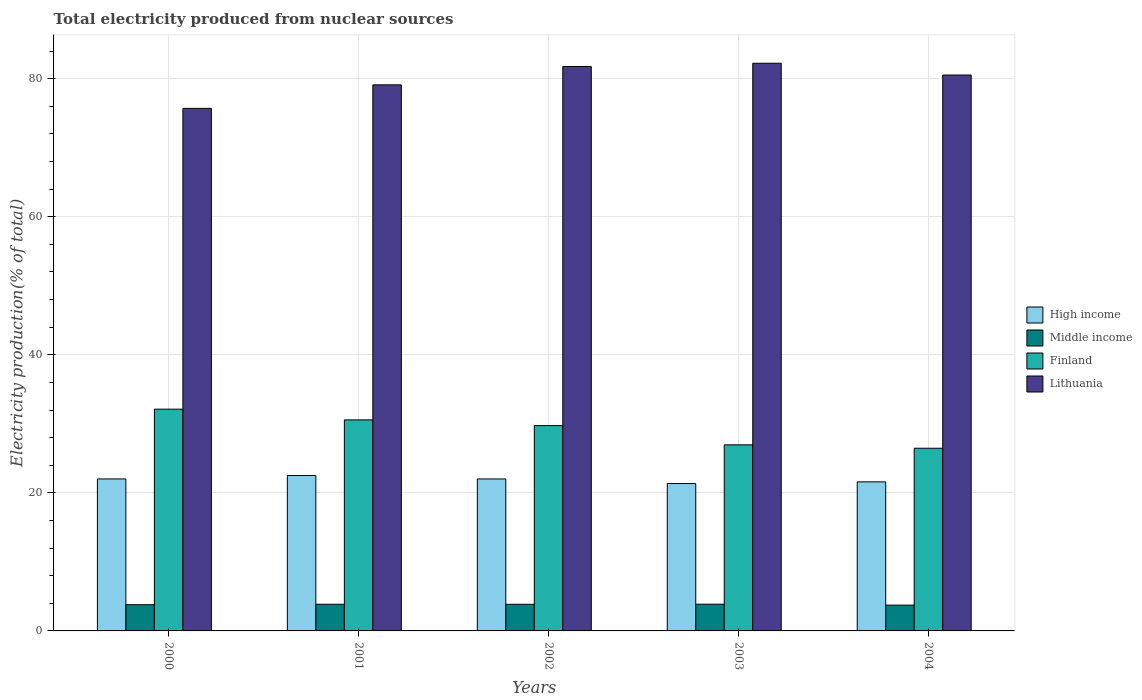How many different coloured bars are there?
Your answer should be very brief. 4. How many groups of bars are there?
Keep it short and to the point. 5. Are the number of bars on each tick of the X-axis equal?
Make the answer very short. Yes. What is the label of the 1st group of bars from the left?
Provide a succinct answer. 2000. In how many cases, is the number of bars for a given year not equal to the number of legend labels?
Offer a very short reply. 0. What is the total electricity produced in Middle income in 2003?
Your answer should be very brief. 3.87. Across all years, what is the maximum total electricity produced in High income?
Make the answer very short. 22.51. Across all years, what is the minimum total electricity produced in Middle income?
Your answer should be very brief. 3.74. In which year was the total electricity produced in Middle income maximum?
Provide a short and direct response. 2003. In which year was the total electricity produced in Lithuania minimum?
Give a very brief answer. 2000. What is the total total electricity produced in Middle income in the graph?
Provide a succinct answer. 19.13. What is the difference between the total electricity produced in High income in 2002 and that in 2004?
Offer a very short reply. 0.42. What is the difference between the total electricity produced in Middle income in 2001 and the total electricity produced in Lithuania in 2004?
Ensure brevity in your answer.  -76.67. What is the average total electricity produced in High income per year?
Offer a terse response. 21.9. In the year 2004, what is the difference between the total electricity produced in High income and total electricity produced in Middle income?
Your response must be concise. 17.86. In how many years, is the total electricity produced in Middle income greater than 12 %?
Ensure brevity in your answer.  0. What is the ratio of the total electricity produced in Lithuania in 2002 to that in 2004?
Your answer should be very brief. 1.02. Is the total electricity produced in High income in 2002 less than that in 2004?
Keep it short and to the point. No. Is the difference between the total electricity produced in High income in 2002 and 2003 greater than the difference between the total electricity produced in Middle income in 2002 and 2003?
Your answer should be compact. Yes. What is the difference between the highest and the second highest total electricity produced in Lithuania?
Make the answer very short. 0.47. What is the difference between the highest and the lowest total electricity produced in High income?
Provide a succinct answer. 1.16. Is it the case that in every year, the sum of the total electricity produced in Finland and total electricity produced in High income is greater than the sum of total electricity produced in Middle income and total electricity produced in Lithuania?
Offer a very short reply. Yes. What does the 2nd bar from the right in 2004 represents?
Your response must be concise. Finland. Is it the case that in every year, the sum of the total electricity produced in Lithuania and total electricity produced in High income is greater than the total electricity produced in Middle income?
Provide a short and direct response. Yes. Does the graph contain any zero values?
Your response must be concise. No. Where does the legend appear in the graph?
Keep it short and to the point. Center right. How are the legend labels stacked?
Keep it short and to the point. Vertical. What is the title of the graph?
Make the answer very short. Total electricity produced from nuclear sources. Does "Somalia" appear as one of the legend labels in the graph?
Make the answer very short. No. What is the label or title of the X-axis?
Your response must be concise. Years. What is the Electricity production(% of total) of High income in 2000?
Offer a terse response. 22.02. What is the Electricity production(% of total) in Middle income in 2000?
Keep it short and to the point. 3.8. What is the Electricity production(% of total) in Finland in 2000?
Provide a succinct answer. 32.13. What is the Electricity production(% of total) of Lithuania in 2000?
Make the answer very short. 75.7. What is the Electricity production(% of total) in High income in 2001?
Your response must be concise. 22.51. What is the Electricity production(% of total) in Middle income in 2001?
Make the answer very short. 3.86. What is the Electricity production(% of total) of Finland in 2001?
Keep it short and to the point. 30.57. What is the Electricity production(% of total) of Lithuania in 2001?
Your response must be concise. 79.11. What is the Electricity production(% of total) of High income in 2002?
Give a very brief answer. 22.02. What is the Electricity production(% of total) in Middle income in 2002?
Give a very brief answer. 3.86. What is the Electricity production(% of total) in Finland in 2002?
Offer a very short reply. 29.75. What is the Electricity production(% of total) in Lithuania in 2002?
Provide a short and direct response. 81.77. What is the Electricity production(% of total) of High income in 2003?
Offer a very short reply. 21.35. What is the Electricity production(% of total) of Middle income in 2003?
Your answer should be compact. 3.87. What is the Electricity production(% of total) in Finland in 2003?
Provide a succinct answer. 26.96. What is the Electricity production(% of total) in Lithuania in 2003?
Provide a succinct answer. 82.24. What is the Electricity production(% of total) of High income in 2004?
Give a very brief answer. 21.59. What is the Electricity production(% of total) of Middle income in 2004?
Offer a terse response. 3.74. What is the Electricity production(% of total) in Finland in 2004?
Ensure brevity in your answer.  26.47. What is the Electricity production(% of total) of Lithuania in 2004?
Your answer should be compact. 80.54. Across all years, what is the maximum Electricity production(% of total) in High income?
Provide a short and direct response. 22.51. Across all years, what is the maximum Electricity production(% of total) of Middle income?
Make the answer very short. 3.87. Across all years, what is the maximum Electricity production(% of total) of Finland?
Provide a short and direct response. 32.13. Across all years, what is the maximum Electricity production(% of total) of Lithuania?
Your response must be concise. 82.24. Across all years, what is the minimum Electricity production(% of total) of High income?
Provide a short and direct response. 21.35. Across all years, what is the minimum Electricity production(% of total) in Middle income?
Your response must be concise. 3.74. Across all years, what is the minimum Electricity production(% of total) in Finland?
Offer a very short reply. 26.47. Across all years, what is the minimum Electricity production(% of total) in Lithuania?
Keep it short and to the point. 75.7. What is the total Electricity production(% of total) in High income in the graph?
Your answer should be compact. 109.5. What is the total Electricity production(% of total) in Middle income in the graph?
Your answer should be very brief. 19.13. What is the total Electricity production(% of total) of Finland in the graph?
Your answer should be very brief. 145.88. What is the total Electricity production(% of total) in Lithuania in the graph?
Provide a short and direct response. 399.36. What is the difference between the Electricity production(% of total) of High income in 2000 and that in 2001?
Your response must be concise. -0.49. What is the difference between the Electricity production(% of total) in Middle income in 2000 and that in 2001?
Make the answer very short. -0.07. What is the difference between the Electricity production(% of total) in Finland in 2000 and that in 2001?
Your answer should be compact. 1.55. What is the difference between the Electricity production(% of total) of Lithuania in 2000 and that in 2001?
Keep it short and to the point. -3.41. What is the difference between the Electricity production(% of total) of High income in 2000 and that in 2002?
Provide a short and direct response. 0. What is the difference between the Electricity production(% of total) in Middle income in 2000 and that in 2002?
Your answer should be very brief. -0.06. What is the difference between the Electricity production(% of total) of Finland in 2000 and that in 2002?
Provide a short and direct response. 2.38. What is the difference between the Electricity production(% of total) in Lithuania in 2000 and that in 2002?
Provide a succinct answer. -6.07. What is the difference between the Electricity production(% of total) of High income in 2000 and that in 2003?
Provide a short and direct response. 0.67. What is the difference between the Electricity production(% of total) in Middle income in 2000 and that in 2003?
Your answer should be compact. -0.08. What is the difference between the Electricity production(% of total) of Finland in 2000 and that in 2003?
Make the answer very short. 5.17. What is the difference between the Electricity production(% of total) of Lithuania in 2000 and that in 2003?
Make the answer very short. -6.54. What is the difference between the Electricity production(% of total) in High income in 2000 and that in 2004?
Give a very brief answer. 0.43. What is the difference between the Electricity production(% of total) in Middle income in 2000 and that in 2004?
Your answer should be very brief. 0.06. What is the difference between the Electricity production(% of total) in Finland in 2000 and that in 2004?
Provide a succinct answer. 5.66. What is the difference between the Electricity production(% of total) of Lithuania in 2000 and that in 2004?
Offer a very short reply. -4.83. What is the difference between the Electricity production(% of total) of High income in 2001 and that in 2002?
Your response must be concise. 0.49. What is the difference between the Electricity production(% of total) in Middle income in 2001 and that in 2002?
Provide a short and direct response. 0. What is the difference between the Electricity production(% of total) of Finland in 2001 and that in 2002?
Your answer should be compact. 0.83. What is the difference between the Electricity production(% of total) in Lithuania in 2001 and that in 2002?
Ensure brevity in your answer.  -2.66. What is the difference between the Electricity production(% of total) in High income in 2001 and that in 2003?
Provide a succinct answer. 1.16. What is the difference between the Electricity production(% of total) in Middle income in 2001 and that in 2003?
Offer a very short reply. -0.01. What is the difference between the Electricity production(% of total) in Finland in 2001 and that in 2003?
Give a very brief answer. 3.61. What is the difference between the Electricity production(% of total) in Lithuania in 2001 and that in 2003?
Ensure brevity in your answer.  -3.13. What is the difference between the Electricity production(% of total) of High income in 2001 and that in 2004?
Your answer should be compact. 0.92. What is the difference between the Electricity production(% of total) of Middle income in 2001 and that in 2004?
Ensure brevity in your answer.  0.13. What is the difference between the Electricity production(% of total) of Finland in 2001 and that in 2004?
Offer a very short reply. 4.11. What is the difference between the Electricity production(% of total) of Lithuania in 2001 and that in 2004?
Make the answer very short. -1.42. What is the difference between the Electricity production(% of total) in High income in 2002 and that in 2003?
Your response must be concise. 0.67. What is the difference between the Electricity production(% of total) of Middle income in 2002 and that in 2003?
Give a very brief answer. -0.01. What is the difference between the Electricity production(% of total) in Finland in 2002 and that in 2003?
Your response must be concise. 2.79. What is the difference between the Electricity production(% of total) in Lithuania in 2002 and that in 2003?
Make the answer very short. -0.47. What is the difference between the Electricity production(% of total) in High income in 2002 and that in 2004?
Ensure brevity in your answer.  0.42. What is the difference between the Electricity production(% of total) in Middle income in 2002 and that in 2004?
Offer a terse response. 0.12. What is the difference between the Electricity production(% of total) in Finland in 2002 and that in 2004?
Your response must be concise. 3.28. What is the difference between the Electricity production(% of total) of Lithuania in 2002 and that in 2004?
Provide a succinct answer. 1.24. What is the difference between the Electricity production(% of total) in High income in 2003 and that in 2004?
Offer a terse response. -0.24. What is the difference between the Electricity production(% of total) in Middle income in 2003 and that in 2004?
Keep it short and to the point. 0.14. What is the difference between the Electricity production(% of total) of Finland in 2003 and that in 2004?
Your response must be concise. 0.49. What is the difference between the Electricity production(% of total) in Lithuania in 2003 and that in 2004?
Provide a succinct answer. 1.7. What is the difference between the Electricity production(% of total) in High income in 2000 and the Electricity production(% of total) in Middle income in 2001?
Keep it short and to the point. 18.16. What is the difference between the Electricity production(% of total) in High income in 2000 and the Electricity production(% of total) in Finland in 2001?
Keep it short and to the point. -8.55. What is the difference between the Electricity production(% of total) in High income in 2000 and the Electricity production(% of total) in Lithuania in 2001?
Ensure brevity in your answer.  -57.09. What is the difference between the Electricity production(% of total) in Middle income in 2000 and the Electricity production(% of total) in Finland in 2001?
Offer a very short reply. -26.78. What is the difference between the Electricity production(% of total) in Middle income in 2000 and the Electricity production(% of total) in Lithuania in 2001?
Your answer should be compact. -75.31. What is the difference between the Electricity production(% of total) of Finland in 2000 and the Electricity production(% of total) of Lithuania in 2001?
Give a very brief answer. -46.98. What is the difference between the Electricity production(% of total) in High income in 2000 and the Electricity production(% of total) in Middle income in 2002?
Keep it short and to the point. 18.16. What is the difference between the Electricity production(% of total) of High income in 2000 and the Electricity production(% of total) of Finland in 2002?
Provide a succinct answer. -7.73. What is the difference between the Electricity production(% of total) of High income in 2000 and the Electricity production(% of total) of Lithuania in 2002?
Ensure brevity in your answer.  -59.75. What is the difference between the Electricity production(% of total) of Middle income in 2000 and the Electricity production(% of total) of Finland in 2002?
Make the answer very short. -25.95. What is the difference between the Electricity production(% of total) of Middle income in 2000 and the Electricity production(% of total) of Lithuania in 2002?
Give a very brief answer. -77.98. What is the difference between the Electricity production(% of total) in Finland in 2000 and the Electricity production(% of total) in Lithuania in 2002?
Your answer should be compact. -49.65. What is the difference between the Electricity production(% of total) of High income in 2000 and the Electricity production(% of total) of Middle income in 2003?
Offer a terse response. 18.15. What is the difference between the Electricity production(% of total) of High income in 2000 and the Electricity production(% of total) of Finland in 2003?
Offer a terse response. -4.94. What is the difference between the Electricity production(% of total) of High income in 2000 and the Electricity production(% of total) of Lithuania in 2003?
Ensure brevity in your answer.  -60.22. What is the difference between the Electricity production(% of total) in Middle income in 2000 and the Electricity production(% of total) in Finland in 2003?
Provide a succinct answer. -23.16. What is the difference between the Electricity production(% of total) in Middle income in 2000 and the Electricity production(% of total) in Lithuania in 2003?
Provide a short and direct response. -78.44. What is the difference between the Electricity production(% of total) of Finland in 2000 and the Electricity production(% of total) of Lithuania in 2003?
Keep it short and to the point. -50.11. What is the difference between the Electricity production(% of total) of High income in 2000 and the Electricity production(% of total) of Middle income in 2004?
Provide a succinct answer. 18.28. What is the difference between the Electricity production(% of total) in High income in 2000 and the Electricity production(% of total) in Finland in 2004?
Provide a short and direct response. -4.45. What is the difference between the Electricity production(% of total) of High income in 2000 and the Electricity production(% of total) of Lithuania in 2004?
Ensure brevity in your answer.  -58.52. What is the difference between the Electricity production(% of total) of Middle income in 2000 and the Electricity production(% of total) of Finland in 2004?
Keep it short and to the point. -22.67. What is the difference between the Electricity production(% of total) of Middle income in 2000 and the Electricity production(% of total) of Lithuania in 2004?
Give a very brief answer. -76.74. What is the difference between the Electricity production(% of total) in Finland in 2000 and the Electricity production(% of total) in Lithuania in 2004?
Provide a succinct answer. -48.41. What is the difference between the Electricity production(% of total) in High income in 2001 and the Electricity production(% of total) in Middle income in 2002?
Offer a very short reply. 18.65. What is the difference between the Electricity production(% of total) of High income in 2001 and the Electricity production(% of total) of Finland in 2002?
Provide a short and direct response. -7.24. What is the difference between the Electricity production(% of total) in High income in 2001 and the Electricity production(% of total) in Lithuania in 2002?
Offer a very short reply. -59.26. What is the difference between the Electricity production(% of total) of Middle income in 2001 and the Electricity production(% of total) of Finland in 2002?
Keep it short and to the point. -25.89. What is the difference between the Electricity production(% of total) in Middle income in 2001 and the Electricity production(% of total) in Lithuania in 2002?
Ensure brevity in your answer.  -77.91. What is the difference between the Electricity production(% of total) in Finland in 2001 and the Electricity production(% of total) in Lithuania in 2002?
Your answer should be compact. -51.2. What is the difference between the Electricity production(% of total) in High income in 2001 and the Electricity production(% of total) in Middle income in 2003?
Your answer should be very brief. 18.64. What is the difference between the Electricity production(% of total) in High income in 2001 and the Electricity production(% of total) in Finland in 2003?
Provide a succinct answer. -4.45. What is the difference between the Electricity production(% of total) in High income in 2001 and the Electricity production(% of total) in Lithuania in 2003?
Ensure brevity in your answer.  -59.73. What is the difference between the Electricity production(% of total) of Middle income in 2001 and the Electricity production(% of total) of Finland in 2003?
Provide a short and direct response. -23.1. What is the difference between the Electricity production(% of total) in Middle income in 2001 and the Electricity production(% of total) in Lithuania in 2003?
Provide a short and direct response. -78.38. What is the difference between the Electricity production(% of total) in Finland in 2001 and the Electricity production(% of total) in Lithuania in 2003?
Your response must be concise. -51.66. What is the difference between the Electricity production(% of total) in High income in 2001 and the Electricity production(% of total) in Middle income in 2004?
Your answer should be very brief. 18.78. What is the difference between the Electricity production(% of total) in High income in 2001 and the Electricity production(% of total) in Finland in 2004?
Offer a terse response. -3.95. What is the difference between the Electricity production(% of total) in High income in 2001 and the Electricity production(% of total) in Lithuania in 2004?
Offer a very short reply. -58.02. What is the difference between the Electricity production(% of total) in Middle income in 2001 and the Electricity production(% of total) in Finland in 2004?
Give a very brief answer. -22.6. What is the difference between the Electricity production(% of total) in Middle income in 2001 and the Electricity production(% of total) in Lithuania in 2004?
Give a very brief answer. -76.67. What is the difference between the Electricity production(% of total) of Finland in 2001 and the Electricity production(% of total) of Lithuania in 2004?
Your answer should be compact. -49.96. What is the difference between the Electricity production(% of total) of High income in 2002 and the Electricity production(% of total) of Middle income in 2003?
Give a very brief answer. 18.15. What is the difference between the Electricity production(% of total) of High income in 2002 and the Electricity production(% of total) of Finland in 2003?
Offer a terse response. -4.94. What is the difference between the Electricity production(% of total) of High income in 2002 and the Electricity production(% of total) of Lithuania in 2003?
Your response must be concise. -60.22. What is the difference between the Electricity production(% of total) of Middle income in 2002 and the Electricity production(% of total) of Finland in 2003?
Ensure brevity in your answer.  -23.1. What is the difference between the Electricity production(% of total) in Middle income in 2002 and the Electricity production(% of total) in Lithuania in 2003?
Offer a very short reply. -78.38. What is the difference between the Electricity production(% of total) of Finland in 2002 and the Electricity production(% of total) of Lithuania in 2003?
Ensure brevity in your answer.  -52.49. What is the difference between the Electricity production(% of total) in High income in 2002 and the Electricity production(% of total) in Middle income in 2004?
Make the answer very short. 18.28. What is the difference between the Electricity production(% of total) of High income in 2002 and the Electricity production(% of total) of Finland in 2004?
Keep it short and to the point. -4.45. What is the difference between the Electricity production(% of total) in High income in 2002 and the Electricity production(% of total) in Lithuania in 2004?
Keep it short and to the point. -58.52. What is the difference between the Electricity production(% of total) in Middle income in 2002 and the Electricity production(% of total) in Finland in 2004?
Your answer should be compact. -22.61. What is the difference between the Electricity production(% of total) in Middle income in 2002 and the Electricity production(% of total) in Lithuania in 2004?
Ensure brevity in your answer.  -76.68. What is the difference between the Electricity production(% of total) in Finland in 2002 and the Electricity production(% of total) in Lithuania in 2004?
Your answer should be compact. -50.79. What is the difference between the Electricity production(% of total) in High income in 2003 and the Electricity production(% of total) in Middle income in 2004?
Ensure brevity in your answer.  17.62. What is the difference between the Electricity production(% of total) of High income in 2003 and the Electricity production(% of total) of Finland in 2004?
Your answer should be very brief. -5.11. What is the difference between the Electricity production(% of total) of High income in 2003 and the Electricity production(% of total) of Lithuania in 2004?
Offer a very short reply. -59.18. What is the difference between the Electricity production(% of total) in Middle income in 2003 and the Electricity production(% of total) in Finland in 2004?
Offer a terse response. -22.59. What is the difference between the Electricity production(% of total) of Middle income in 2003 and the Electricity production(% of total) of Lithuania in 2004?
Your answer should be very brief. -76.66. What is the difference between the Electricity production(% of total) of Finland in 2003 and the Electricity production(% of total) of Lithuania in 2004?
Offer a very short reply. -53.57. What is the average Electricity production(% of total) of High income per year?
Ensure brevity in your answer.  21.9. What is the average Electricity production(% of total) in Middle income per year?
Your answer should be very brief. 3.83. What is the average Electricity production(% of total) of Finland per year?
Offer a terse response. 29.18. What is the average Electricity production(% of total) in Lithuania per year?
Give a very brief answer. 79.87. In the year 2000, what is the difference between the Electricity production(% of total) of High income and Electricity production(% of total) of Middle income?
Keep it short and to the point. 18.22. In the year 2000, what is the difference between the Electricity production(% of total) in High income and Electricity production(% of total) in Finland?
Offer a terse response. -10.11. In the year 2000, what is the difference between the Electricity production(% of total) of High income and Electricity production(% of total) of Lithuania?
Your answer should be compact. -53.68. In the year 2000, what is the difference between the Electricity production(% of total) of Middle income and Electricity production(% of total) of Finland?
Provide a succinct answer. -28.33. In the year 2000, what is the difference between the Electricity production(% of total) in Middle income and Electricity production(% of total) in Lithuania?
Your response must be concise. -71.91. In the year 2000, what is the difference between the Electricity production(% of total) in Finland and Electricity production(% of total) in Lithuania?
Your answer should be compact. -43.58. In the year 2001, what is the difference between the Electricity production(% of total) of High income and Electricity production(% of total) of Middle income?
Offer a very short reply. 18.65. In the year 2001, what is the difference between the Electricity production(% of total) of High income and Electricity production(% of total) of Finland?
Your response must be concise. -8.06. In the year 2001, what is the difference between the Electricity production(% of total) in High income and Electricity production(% of total) in Lithuania?
Your answer should be very brief. -56.6. In the year 2001, what is the difference between the Electricity production(% of total) of Middle income and Electricity production(% of total) of Finland?
Offer a terse response. -26.71. In the year 2001, what is the difference between the Electricity production(% of total) in Middle income and Electricity production(% of total) in Lithuania?
Your response must be concise. -75.25. In the year 2001, what is the difference between the Electricity production(% of total) of Finland and Electricity production(% of total) of Lithuania?
Provide a succinct answer. -48.54. In the year 2002, what is the difference between the Electricity production(% of total) of High income and Electricity production(% of total) of Middle income?
Offer a very short reply. 18.16. In the year 2002, what is the difference between the Electricity production(% of total) of High income and Electricity production(% of total) of Finland?
Keep it short and to the point. -7.73. In the year 2002, what is the difference between the Electricity production(% of total) of High income and Electricity production(% of total) of Lithuania?
Ensure brevity in your answer.  -59.76. In the year 2002, what is the difference between the Electricity production(% of total) of Middle income and Electricity production(% of total) of Finland?
Ensure brevity in your answer.  -25.89. In the year 2002, what is the difference between the Electricity production(% of total) of Middle income and Electricity production(% of total) of Lithuania?
Your answer should be very brief. -77.92. In the year 2002, what is the difference between the Electricity production(% of total) in Finland and Electricity production(% of total) in Lithuania?
Make the answer very short. -52.03. In the year 2003, what is the difference between the Electricity production(% of total) in High income and Electricity production(% of total) in Middle income?
Your response must be concise. 17.48. In the year 2003, what is the difference between the Electricity production(% of total) in High income and Electricity production(% of total) in Finland?
Your answer should be compact. -5.61. In the year 2003, what is the difference between the Electricity production(% of total) of High income and Electricity production(% of total) of Lithuania?
Give a very brief answer. -60.89. In the year 2003, what is the difference between the Electricity production(% of total) in Middle income and Electricity production(% of total) in Finland?
Make the answer very short. -23.09. In the year 2003, what is the difference between the Electricity production(% of total) of Middle income and Electricity production(% of total) of Lithuania?
Offer a terse response. -78.37. In the year 2003, what is the difference between the Electricity production(% of total) of Finland and Electricity production(% of total) of Lithuania?
Your response must be concise. -55.28. In the year 2004, what is the difference between the Electricity production(% of total) of High income and Electricity production(% of total) of Middle income?
Offer a terse response. 17.86. In the year 2004, what is the difference between the Electricity production(% of total) of High income and Electricity production(% of total) of Finland?
Offer a very short reply. -4.87. In the year 2004, what is the difference between the Electricity production(% of total) of High income and Electricity production(% of total) of Lithuania?
Your answer should be very brief. -58.94. In the year 2004, what is the difference between the Electricity production(% of total) of Middle income and Electricity production(% of total) of Finland?
Keep it short and to the point. -22.73. In the year 2004, what is the difference between the Electricity production(% of total) of Middle income and Electricity production(% of total) of Lithuania?
Provide a short and direct response. -76.8. In the year 2004, what is the difference between the Electricity production(% of total) in Finland and Electricity production(% of total) in Lithuania?
Provide a succinct answer. -54.07. What is the ratio of the Electricity production(% of total) of High income in 2000 to that in 2001?
Offer a terse response. 0.98. What is the ratio of the Electricity production(% of total) in Middle income in 2000 to that in 2001?
Ensure brevity in your answer.  0.98. What is the ratio of the Electricity production(% of total) in Finland in 2000 to that in 2001?
Keep it short and to the point. 1.05. What is the ratio of the Electricity production(% of total) of Lithuania in 2000 to that in 2001?
Offer a terse response. 0.96. What is the ratio of the Electricity production(% of total) in Middle income in 2000 to that in 2002?
Ensure brevity in your answer.  0.98. What is the ratio of the Electricity production(% of total) in Lithuania in 2000 to that in 2002?
Your response must be concise. 0.93. What is the ratio of the Electricity production(% of total) of High income in 2000 to that in 2003?
Give a very brief answer. 1.03. What is the ratio of the Electricity production(% of total) of Middle income in 2000 to that in 2003?
Provide a succinct answer. 0.98. What is the ratio of the Electricity production(% of total) in Finland in 2000 to that in 2003?
Your answer should be compact. 1.19. What is the ratio of the Electricity production(% of total) in Lithuania in 2000 to that in 2003?
Give a very brief answer. 0.92. What is the ratio of the Electricity production(% of total) in High income in 2000 to that in 2004?
Your response must be concise. 1.02. What is the ratio of the Electricity production(% of total) of Middle income in 2000 to that in 2004?
Make the answer very short. 1.02. What is the ratio of the Electricity production(% of total) of Finland in 2000 to that in 2004?
Keep it short and to the point. 1.21. What is the ratio of the Electricity production(% of total) of Lithuania in 2000 to that in 2004?
Your response must be concise. 0.94. What is the ratio of the Electricity production(% of total) in High income in 2001 to that in 2002?
Make the answer very short. 1.02. What is the ratio of the Electricity production(% of total) in Finland in 2001 to that in 2002?
Offer a very short reply. 1.03. What is the ratio of the Electricity production(% of total) in Lithuania in 2001 to that in 2002?
Offer a very short reply. 0.97. What is the ratio of the Electricity production(% of total) of High income in 2001 to that in 2003?
Keep it short and to the point. 1.05. What is the ratio of the Electricity production(% of total) in Middle income in 2001 to that in 2003?
Your answer should be very brief. 1. What is the ratio of the Electricity production(% of total) of Finland in 2001 to that in 2003?
Your response must be concise. 1.13. What is the ratio of the Electricity production(% of total) of High income in 2001 to that in 2004?
Provide a succinct answer. 1.04. What is the ratio of the Electricity production(% of total) in Middle income in 2001 to that in 2004?
Keep it short and to the point. 1.03. What is the ratio of the Electricity production(% of total) in Finland in 2001 to that in 2004?
Your answer should be compact. 1.16. What is the ratio of the Electricity production(% of total) in Lithuania in 2001 to that in 2004?
Ensure brevity in your answer.  0.98. What is the ratio of the Electricity production(% of total) of High income in 2002 to that in 2003?
Your answer should be compact. 1.03. What is the ratio of the Electricity production(% of total) of Middle income in 2002 to that in 2003?
Keep it short and to the point. 1. What is the ratio of the Electricity production(% of total) of Finland in 2002 to that in 2003?
Provide a short and direct response. 1.1. What is the ratio of the Electricity production(% of total) of Lithuania in 2002 to that in 2003?
Offer a very short reply. 0.99. What is the ratio of the Electricity production(% of total) of High income in 2002 to that in 2004?
Give a very brief answer. 1.02. What is the ratio of the Electricity production(% of total) in Middle income in 2002 to that in 2004?
Provide a succinct answer. 1.03. What is the ratio of the Electricity production(% of total) in Finland in 2002 to that in 2004?
Your response must be concise. 1.12. What is the ratio of the Electricity production(% of total) in Lithuania in 2002 to that in 2004?
Offer a very short reply. 1.02. What is the ratio of the Electricity production(% of total) in High income in 2003 to that in 2004?
Make the answer very short. 0.99. What is the ratio of the Electricity production(% of total) in Middle income in 2003 to that in 2004?
Your answer should be very brief. 1.04. What is the ratio of the Electricity production(% of total) in Finland in 2003 to that in 2004?
Your answer should be very brief. 1.02. What is the ratio of the Electricity production(% of total) of Lithuania in 2003 to that in 2004?
Provide a short and direct response. 1.02. What is the difference between the highest and the second highest Electricity production(% of total) in High income?
Provide a succinct answer. 0.49. What is the difference between the highest and the second highest Electricity production(% of total) of Middle income?
Your response must be concise. 0.01. What is the difference between the highest and the second highest Electricity production(% of total) of Finland?
Offer a terse response. 1.55. What is the difference between the highest and the second highest Electricity production(% of total) in Lithuania?
Ensure brevity in your answer.  0.47. What is the difference between the highest and the lowest Electricity production(% of total) in High income?
Your answer should be very brief. 1.16. What is the difference between the highest and the lowest Electricity production(% of total) of Middle income?
Your response must be concise. 0.14. What is the difference between the highest and the lowest Electricity production(% of total) of Finland?
Give a very brief answer. 5.66. What is the difference between the highest and the lowest Electricity production(% of total) in Lithuania?
Provide a succinct answer. 6.54. 